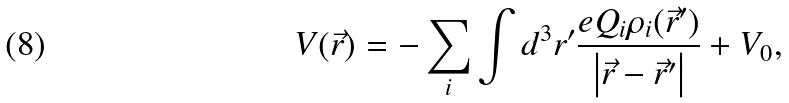Convert formula to latex. <formula><loc_0><loc_0><loc_500><loc_500>V ( \vec { r } ) = - \sum _ { i } \int d ^ { 3 } r ^ { \prime } \frac { e Q _ { i } \rho _ { i } ( \vec { r } ^ { \prime } ) } { \left | \vec { r } - \vec { r } ^ { \prime } \right | } + V _ { 0 } ,</formula> 